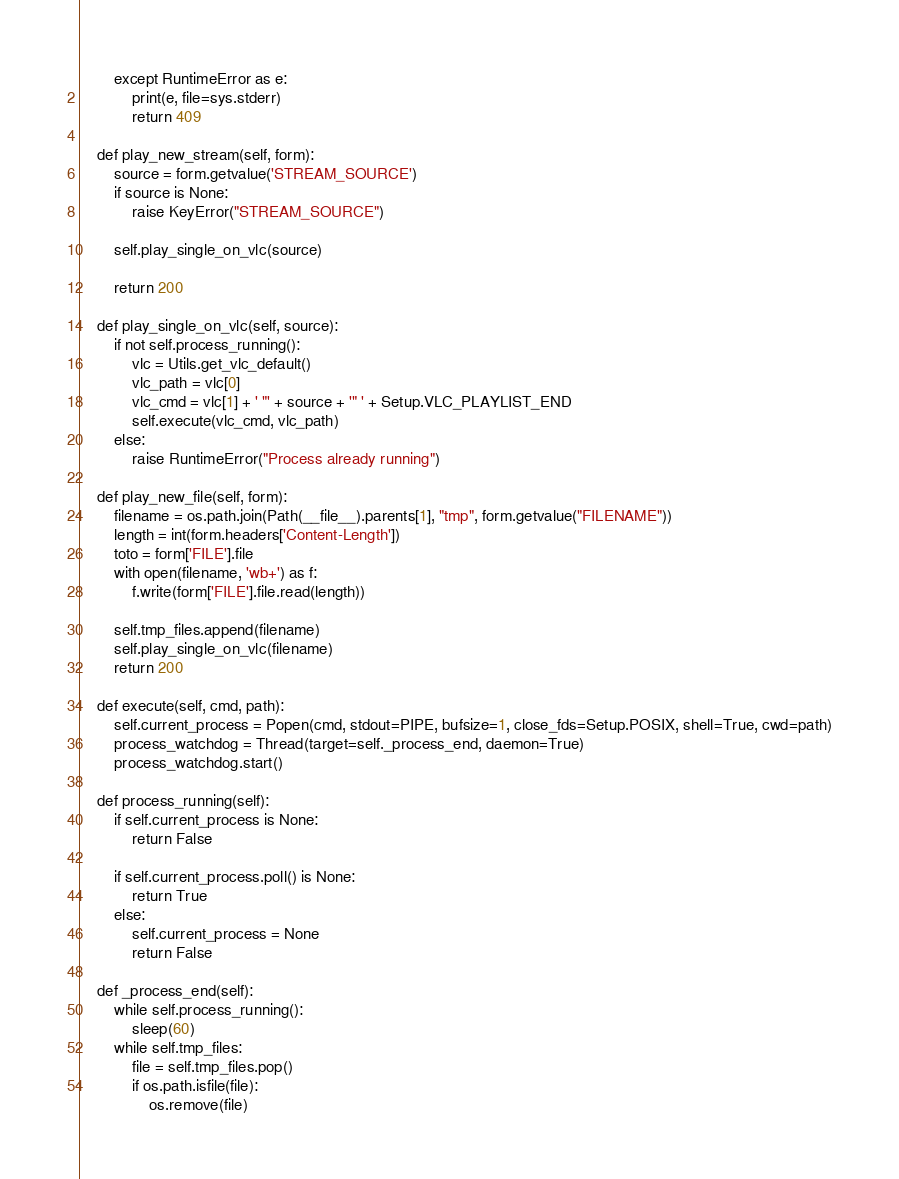<code> <loc_0><loc_0><loc_500><loc_500><_Python_>        except RuntimeError as e:
            print(e, file=sys.stderr)
            return 409

    def play_new_stream(self, form):
        source = form.getvalue('STREAM_SOURCE')
        if source is None:
            raise KeyError("STREAM_SOURCE")

        self.play_single_on_vlc(source)

        return 200

    def play_single_on_vlc(self, source):
        if not self.process_running():
            vlc = Utils.get_vlc_default()
            vlc_path = vlc[0]
            vlc_cmd = vlc[1] + ' "' + source + '" ' + Setup.VLC_PLAYLIST_END
            self.execute(vlc_cmd, vlc_path)
        else:
            raise RuntimeError("Process already running")

    def play_new_file(self, form):
        filename = os.path.join(Path(__file__).parents[1], "tmp", form.getvalue("FILENAME"))
        length = int(form.headers['Content-Length'])
        toto = form['FILE'].file
        with open(filename, 'wb+') as f:
            f.write(form['FILE'].file.read(length))

        self.tmp_files.append(filename)
        self.play_single_on_vlc(filename)
        return 200

    def execute(self, cmd, path):
        self.current_process = Popen(cmd, stdout=PIPE, bufsize=1, close_fds=Setup.POSIX, shell=True, cwd=path)
        process_watchdog = Thread(target=self._process_end, daemon=True)
        process_watchdog.start()

    def process_running(self):
        if self.current_process is None:
            return False

        if self.current_process.poll() is None:
            return True
        else:
            self.current_process = None
            return False

    def _process_end(self):
        while self.process_running():
            sleep(60)
        while self.tmp_files:
            file = self.tmp_files.pop()
            if os.path.isfile(file):
                os.remove(file)
</code> 